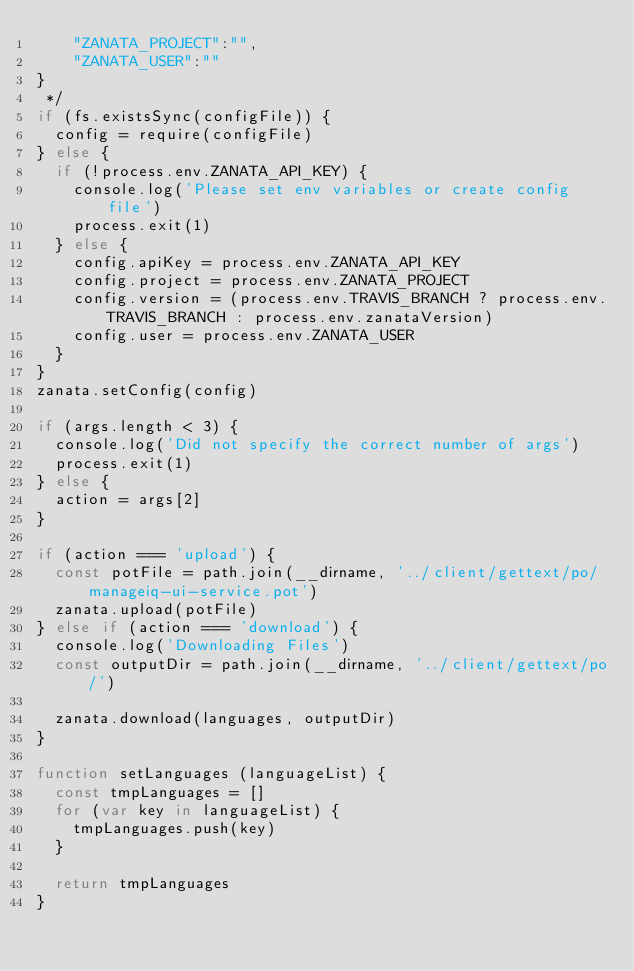<code> <loc_0><loc_0><loc_500><loc_500><_JavaScript_>    "ZANATA_PROJECT":"",
    "ZANATA_USER":""
}
 */
if (fs.existsSync(configFile)) {
  config = require(configFile)
} else {
  if (!process.env.ZANATA_API_KEY) {
    console.log('Please set env variables or create config file')
    process.exit(1)
  } else {
    config.apiKey = process.env.ZANATA_API_KEY
    config.project = process.env.ZANATA_PROJECT
    config.version = (process.env.TRAVIS_BRANCH ? process.env.TRAVIS_BRANCH : process.env.zanataVersion)
    config.user = process.env.ZANATA_USER
  }
}
zanata.setConfig(config)

if (args.length < 3) {
  console.log('Did not specify the correct number of args')
  process.exit(1)
} else {
  action = args[2]
}

if (action === 'upload') {
  const potFile = path.join(__dirname, '../client/gettext/po/manageiq-ui-service.pot')
  zanata.upload(potFile)
} else if (action === 'download') {
  console.log('Downloading Files')
  const outputDir = path.join(__dirname, '../client/gettext/po/')

  zanata.download(languages, outputDir)
}

function setLanguages (languageList) {
  const tmpLanguages = []
  for (var key in languageList) {
    tmpLanguages.push(key)
  }

  return tmpLanguages
}
</code> 